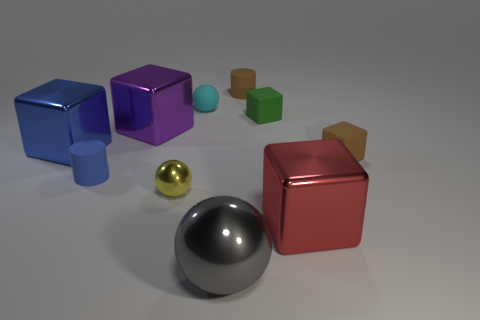Subtract all blue blocks. How many blocks are left? 4 Subtract all brown matte cubes. How many cubes are left? 4 Subtract all cyan blocks. Subtract all red cylinders. How many blocks are left? 5 Subtract all cylinders. How many objects are left? 8 Subtract all purple metallic things. Subtract all large gray metallic balls. How many objects are left? 8 Add 7 cyan objects. How many cyan objects are left? 8 Add 8 small green objects. How many small green objects exist? 9 Subtract 0 yellow blocks. How many objects are left? 10 